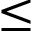<formula> <loc_0><loc_0><loc_500><loc_500>\leq</formula> 